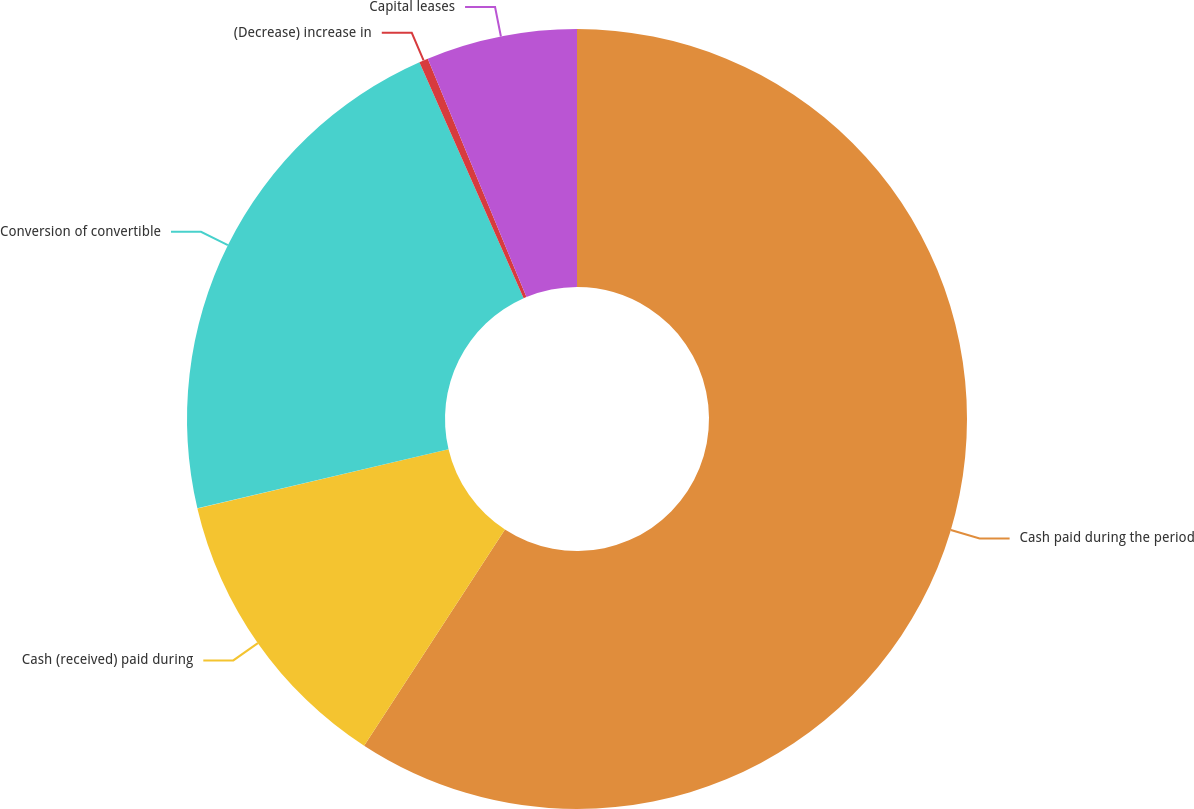Convert chart to OTSL. <chart><loc_0><loc_0><loc_500><loc_500><pie_chart><fcel>Cash paid during the period<fcel>Cash (received) paid during<fcel>Conversion of convertible<fcel>(Decrease) increase in<fcel>Capital leases<nl><fcel>59.19%<fcel>12.13%<fcel>22.06%<fcel>0.37%<fcel>6.25%<nl></chart> 